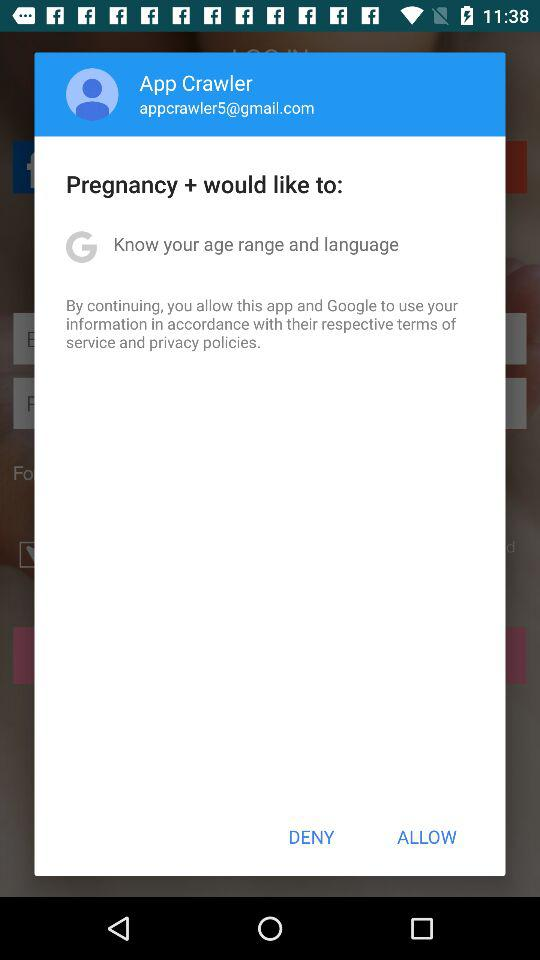What is the email address? The email address is appcrawler5@gmail.com. 